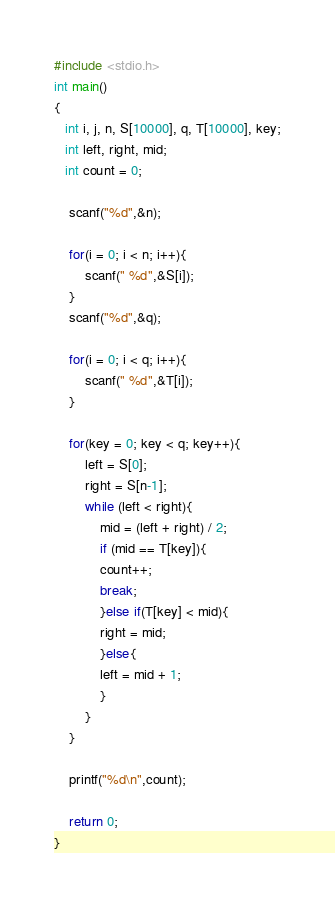Convert code to text. <code><loc_0><loc_0><loc_500><loc_500><_C_>
#include <stdio.h>
int main()
{
   int i, j, n, S[10000], q, T[10000], key;
   int left, right, mid;
   int count = 0;
     
    scanf("%d",&n);
     
    for(i = 0; i < n; i++){
        scanf(" %d",&S[i]);
    }
    scanf("%d",&q);
     
    for(i = 0; i < q; i++){
        scanf(" %d",&T[i]);
    }
    
	for(key = 0; key < q; key++){
		left = S[0];
		right = S[n-1];
		while (left < right){
			mid = (left + right) / 2;
			if (mid == T[key]){ 
			count++;
			break;
			}else if(T[key] < mid){
			right = mid;
			}else{
			left = mid + 1;
			}
		}
	}

	printf("%d\n",count);
	
	return 0;
}</code> 